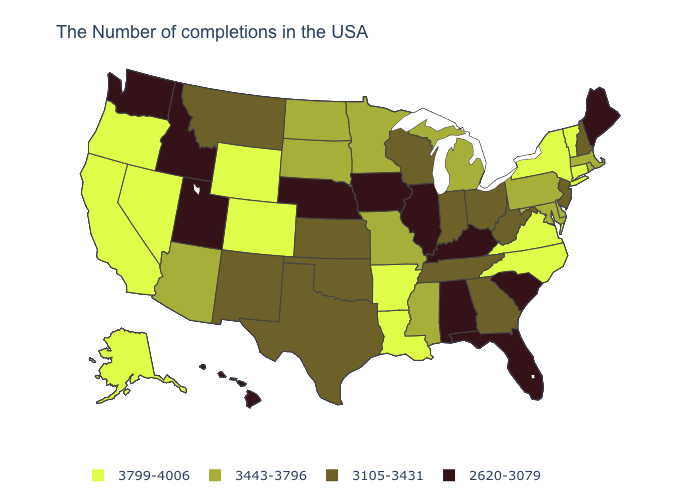Name the states that have a value in the range 3799-4006?
Give a very brief answer. Vermont, Connecticut, New York, Virginia, North Carolina, Louisiana, Arkansas, Wyoming, Colorado, Nevada, California, Oregon, Alaska. What is the value of Virginia?
Be succinct. 3799-4006. Does Michigan have a lower value than Wyoming?
Write a very short answer. Yes. What is the value of Florida?
Answer briefly. 2620-3079. What is the value of Nebraska?
Short answer required. 2620-3079. Does Iowa have the lowest value in the USA?
Quick response, please. Yes. Name the states that have a value in the range 3105-3431?
Give a very brief answer. New Hampshire, New Jersey, West Virginia, Ohio, Georgia, Indiana, Tennessee, Wisconsin, Kansas, Oklahoma, Texas, New Mexico, Montana. Which states have the highest value in the USA?
Quick response, please. Vermont, Connecticut, New York, Virginia, North Carolina, Louisiana, Arkansas, Wyoming, Colorado, Nevada, California, Oregon, Alaska. What is the lowest value in states that border Wisconsin?
Give a very brief answer. 2620-3079. What is the value of Hawaii?
Keep it brief. 2620-3079. What is the lowest value in the Northeast?
Give a very brief answer. 2620-3079. Among the states that border Rhode Island , which have the highest value?
Short answer required. Connecticut. Name the states that have a value in the range 2620-3079?
Keep it brief. Maine, South Carolina, Florida, Kentucky, Alabama, Illinois, Iowa, Nebraska, Utah, Idaho, Washington, Hawaii. Does Minnesota have the same value as Mississippi?
Answer briefly. Yes. Name the states that have a value in the range 2620-3079?
Answer briefly. Maine, South Carolina, Florida, Kentucky, Alabama, Illinois, Iowa, Nebraska, Utah, Idaho, Washington, Hawaii. 